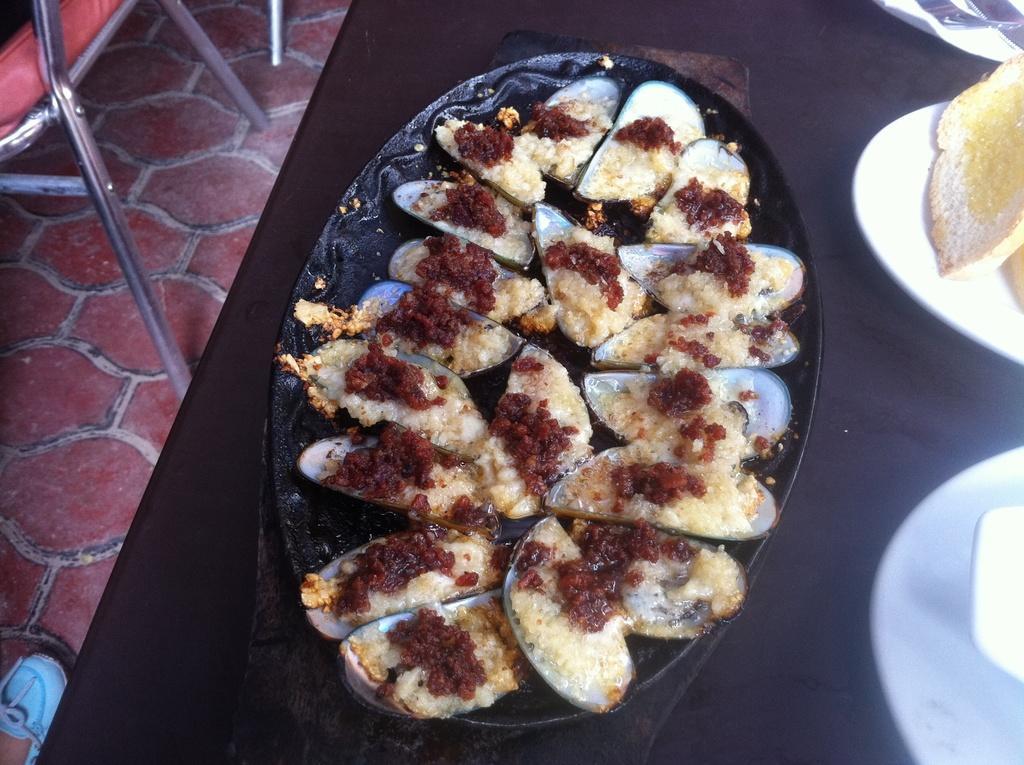Can you describe this image briefly? In this image we can see the plate of food items. We can also see the bread on a white color plate which is on the table. On the left we can see the floor, chairs and also some person's leg. 